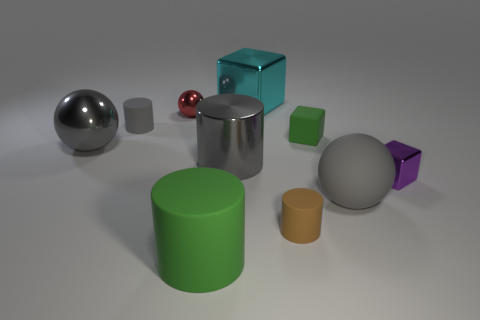Subtract all big cyan cubes. How many cubes are left? 2 Subtract 0 red cylinders. How many objects are left? 10 Subtract all cubes. How many objects are left? 7 Subtract 3 balls. How many balls are left? 0 Subtract all red cylinders. Subtract all cyan blocks. How many cylinders are left? 4 Subtract all green spheres. How many purple cubes are left? 1 Subtract all small blue balls. Subtract all small gray cylinders. How many objects are left? 9 Add 2 tiny shiny objects. How many tiny shiny objects are left? 4 Add 8 large metallic cylinders. How many large metallic cylinders exist? 9 Subtract all cyan cubes. How many cubes are left? 2 